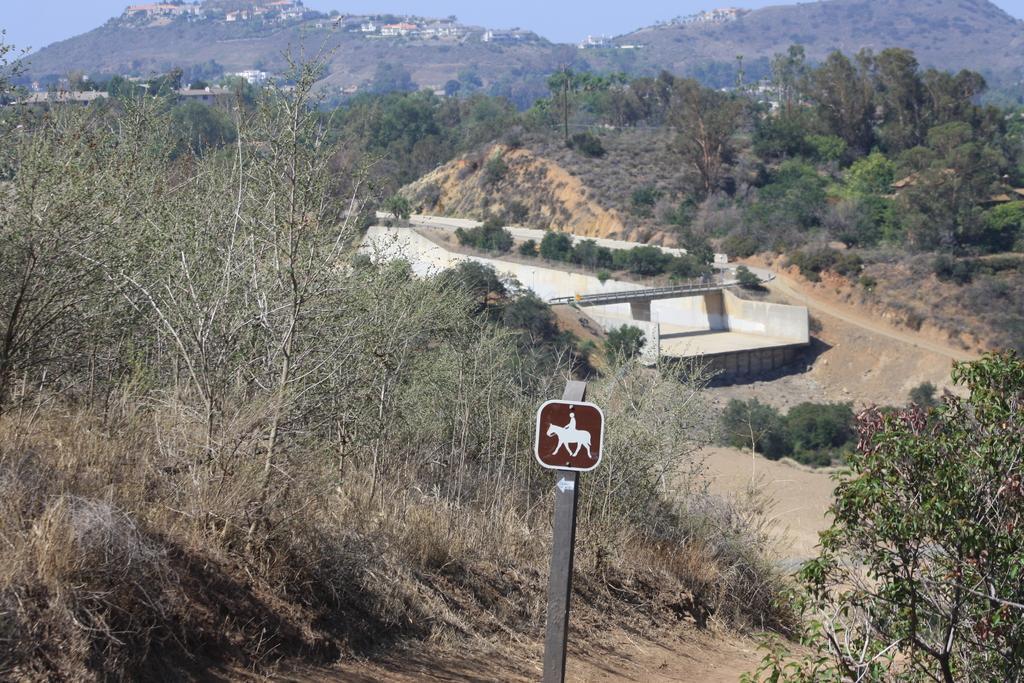How would you summarize this image in a sentence or two? In this image we can see trees, pole, road, bridge, plants, grass, hills, buildings and sky. 